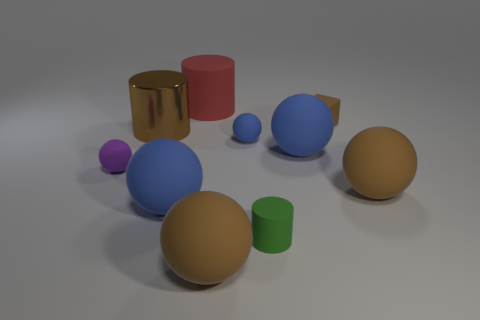Is the number of tiny yellow matte balls less than the number of red matte things? Yes, upon closer inspection of the image, there is only one small yellow matte ball present, while there are two red matte objects; a cylinder and a cube, which means the number of tiny yellow matte balls is indeed less than the number of red matte things. 